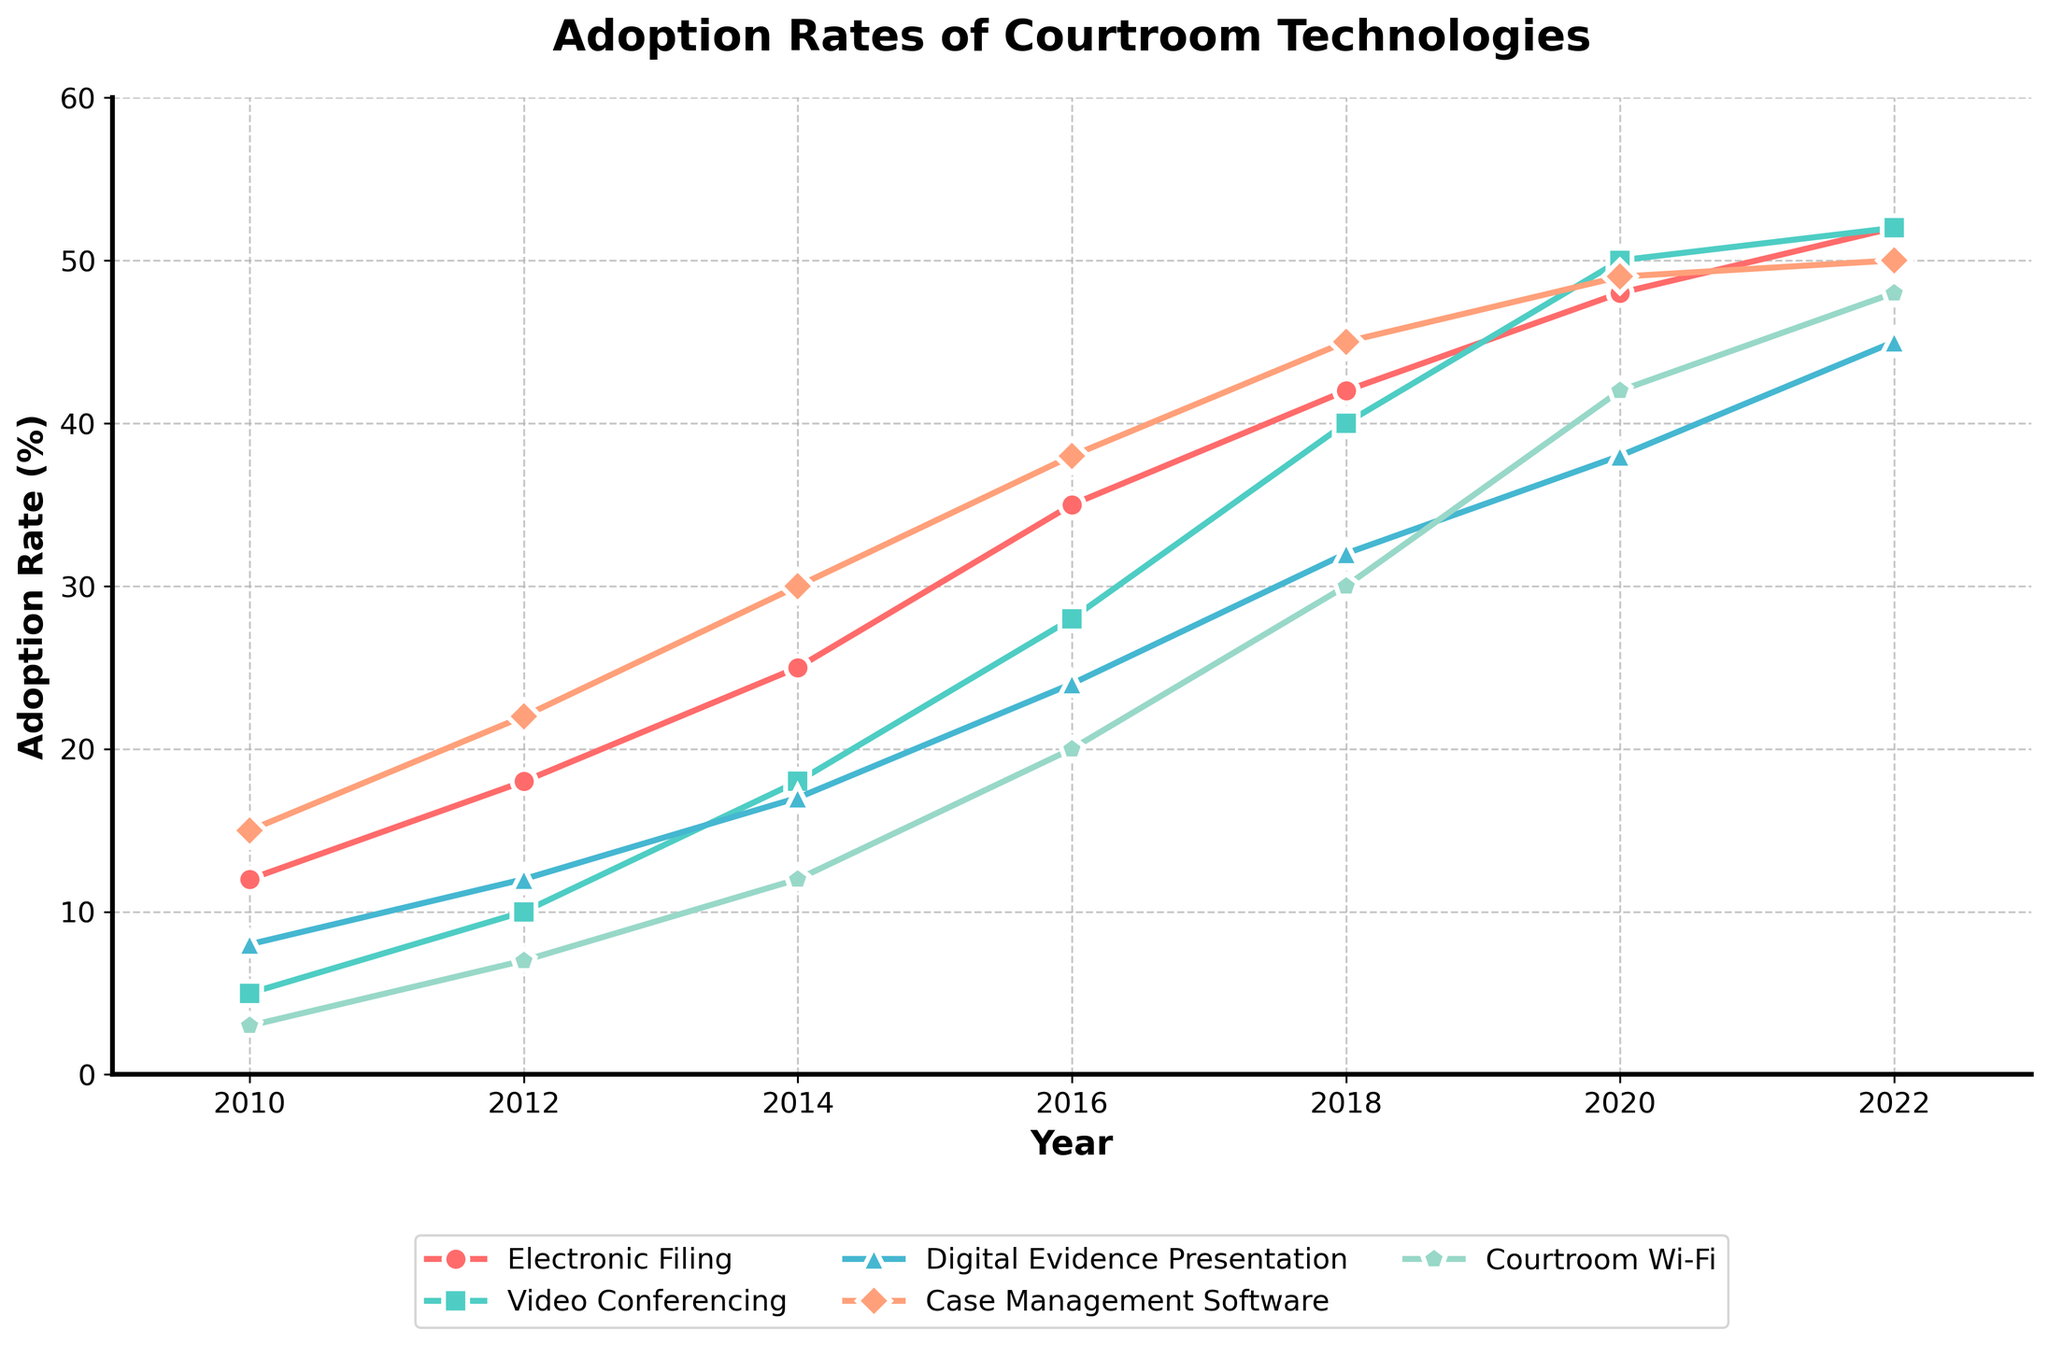What is the adoption rate of Video Conferencing in 2018? Look at the point on the line representing Video Conferencing and year 2018 on the x-axis. The y-axis value at this point is the adoption rate.
Answer: 40 Which technology had the highest adoption rate in 2022? Find the points for various technologies in 2022 on the x-axis. Compare these points' values on the y-axis to determine which is the highest.
Answer: Courtroom Wi-Fi How many years did it take for Electronic Filing to increase from 12% to 48%? Find the points for Electronic Filing with 12% and 48% on the y-axis. The corresponding years are 2010 and 2020. The number of years between these points is 2020 - 2010.
Answer: 10 years Between 2014 and 2020, which technology had the largest increase in adoption rate? Note the adoption rates of all technologies in 2014 and 2020. Subtract the 2014 values from the 2020 values and compare the differences.
Answer: Video Conferencing What is the average adoption rate of Case Management Software from 2010 to 2022? Add the adoption rates of Case Management Software for each year from 2010 to 2022 and divide by the total number of years (7).
Answer: 35 In 2016, which technology had a lower adoption rate: Digital Evidence Presentation or Courtroom Wi-Fi? Look at the points for Digital Evidence Presentation and Courtroom Wi-Fi in 2016. Compare their values on the y-axis.
Answer: Courtroom Wi-Fi Did any technology have a constant increase in adoption rate every year? Check if the adoption rates for each technology increase consistently across all years without any drops or plateaus.
Answer: Yes, Electronic Filing What is the difference in adoption rates of Digital Evidence Presentation between 2012 and 2022? Find the points for Digital Evidence Presentation in 2012 and 2022 and subtract the former value from the latter value.
Answer: 33% Comparing 2016 to 2018, which technology saw the greatest percentage increase? Calculate the percentage increase for each technology by subtracting the 2016 value from the 2018 value, then divide by the 2016 value and multiply by 100. Compare these values.
Answer: Courtroom Wi-Fi 